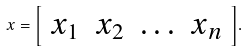<formula> <loc_0><loc_0><loc_500><loc_500>x = { \left [ \begin{array} { l l l l } { x _ { 1 } } & { x _ { 2 } } & { \dots } & { x _ { n } } \end{array} \right ] } .</formula> 